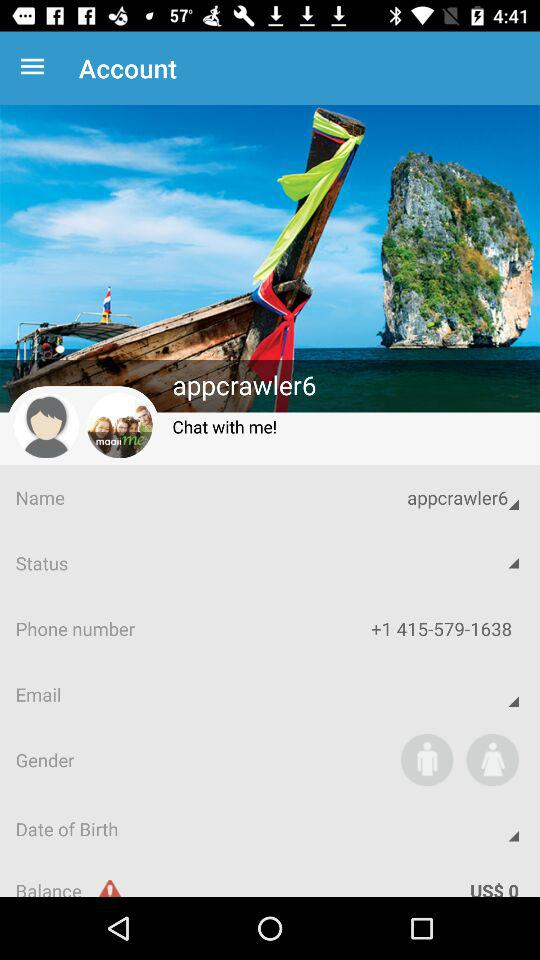What is the phone number? The phone number is +1 415-579-1638. 